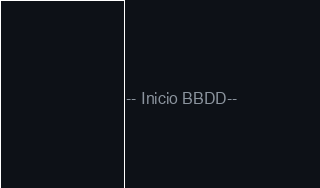Convert code to text. <code><loc_0><loc_0><loc_500><loc_500><_SQL_>-- Inicio BBDD--</code> 